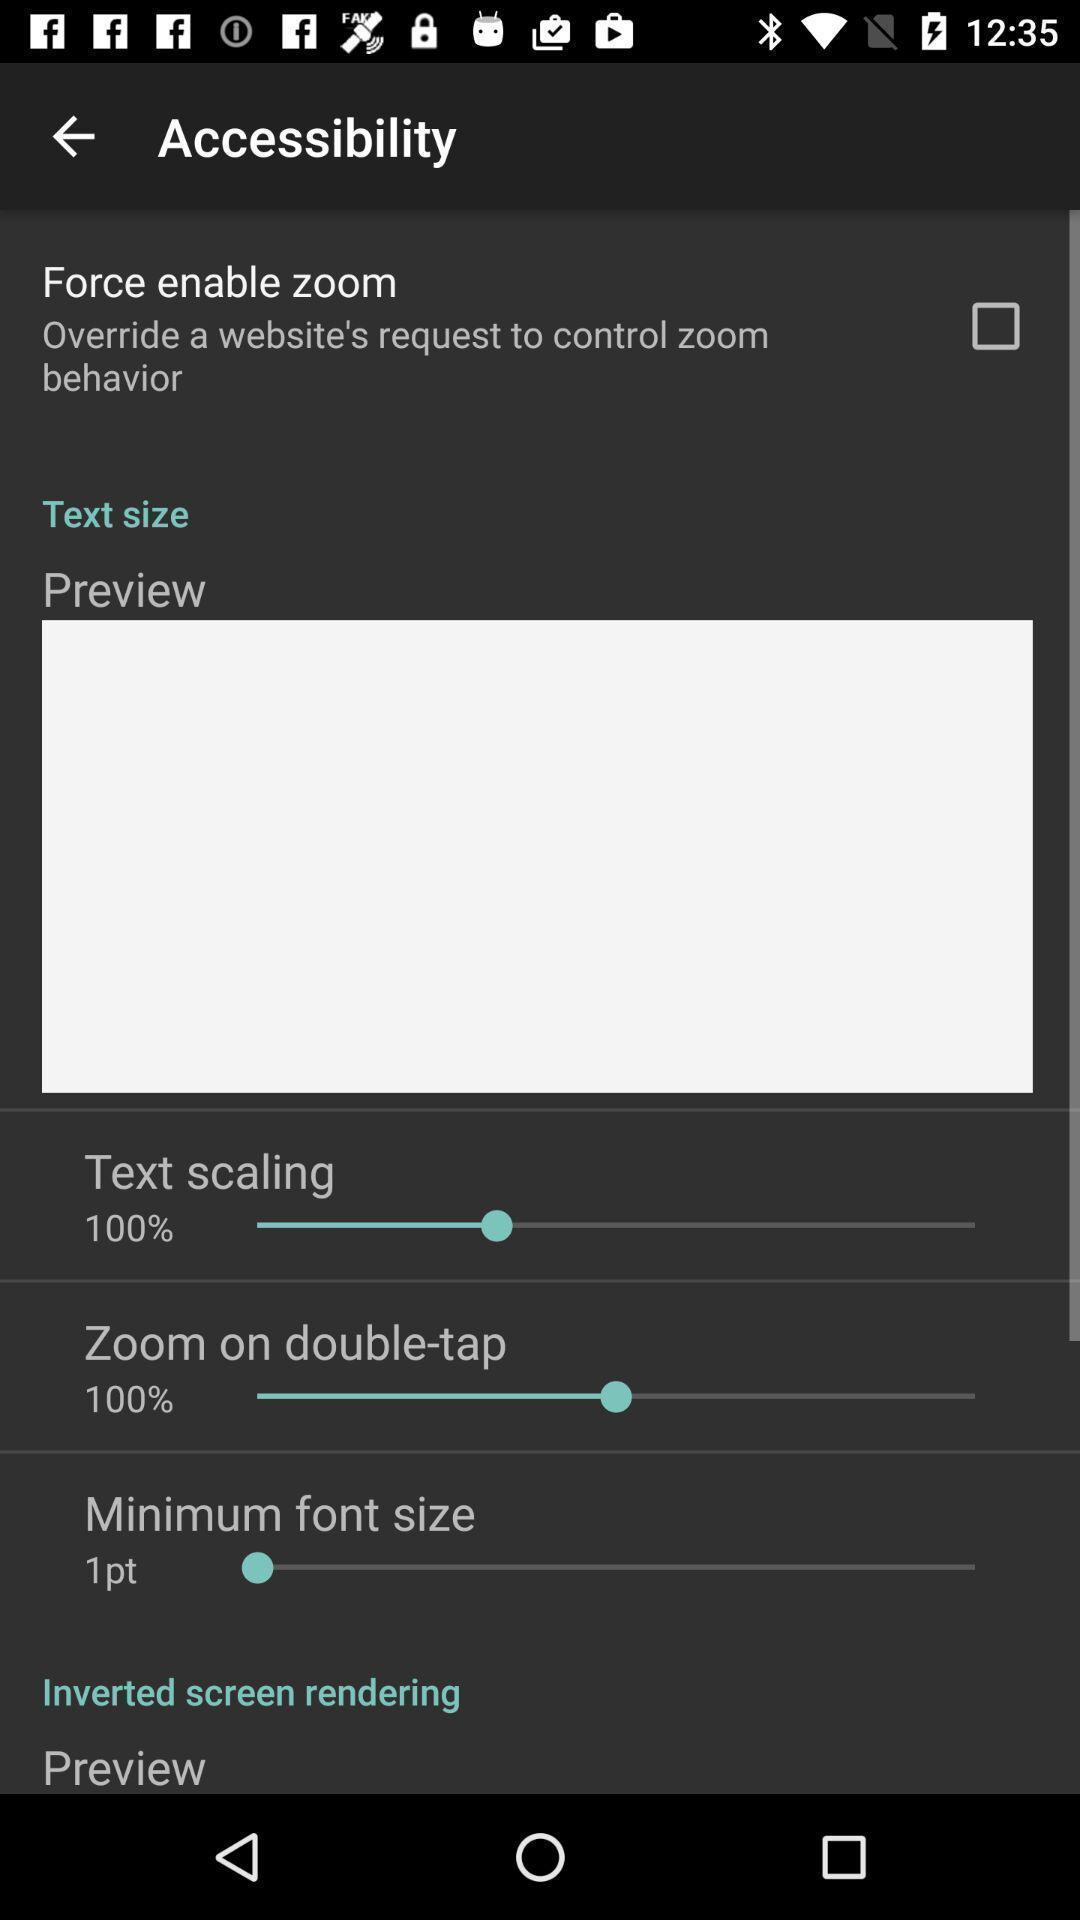What details can you identify in this image? Page showing settings menu. 